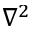<formula> <loc_0><loc_0><loc_500><loc_500>\nabla ^ { 2 }</formula> 